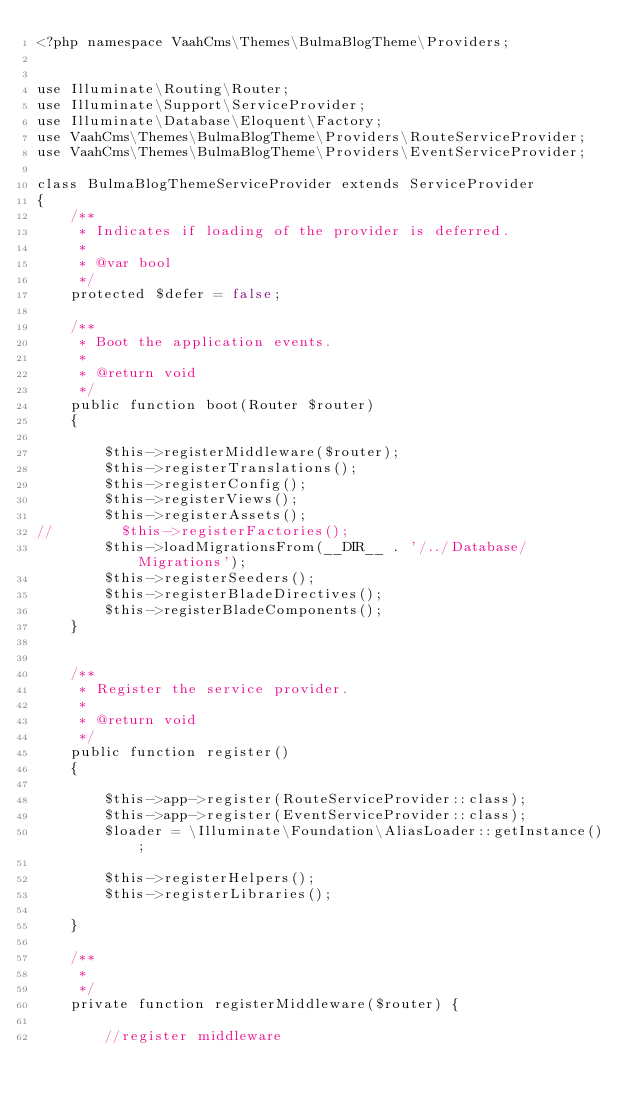Convert code to text. <code><loc_0><loc_0><loc_500><loc_500><_PHP_><?php namespace VaahCms\Themes\BulmaBlogTheme\Providers;


use Illuminate\Routing\Router;
use Illuminate\Support\ServiceProvider;
use Illuminate\Database\Eloquent\Factory;
use VaahCms\Themes\BulmaBlogTheme\Providers\RouteServiceProvider;
use VaahCms\Themes\BulmaBlogTheme\Providers\EventServiceProvider;

class BulmaBlogThemeServiceProvider extends ServiceProvider
{
    /**
     * Indicates if loading of the provider is deferred.
     *
     * @var bool
     */
    protected $defer = false;

    /**
     * Boot the application events.
     *
     * @return void
     */
    public function boot(Router $router)
    {

        $this->registerMiddleware($router);
        $this->registerTranslations();
        $this->registerConfig();
        $this->registerViews();
        $this->registerAssets();
//        $this->registerFactories();
        $this->loadMigrationsFrom(__DIR__ . '/../Database/Migrations');
        $this->registerSeeders();
        $this->registerBladeDirectives();
        $this->registerBladeComponents();
    }


    /**
     * Register the service provider.
     *
     * @return void
     */
    public function register()
    {

        $this->app->register(RouteServiceProvider::class);
        $this->app->register(EventServiceProvider::class);
        $loader = \Illuminate\Foundation\AliasLoader::getInstance();

        $this->registerHelpers();
        $this->registerLibraries();

    }

    /**
     *
     */
    private function registerMiddleware($router) {

        //register middleware</code> 